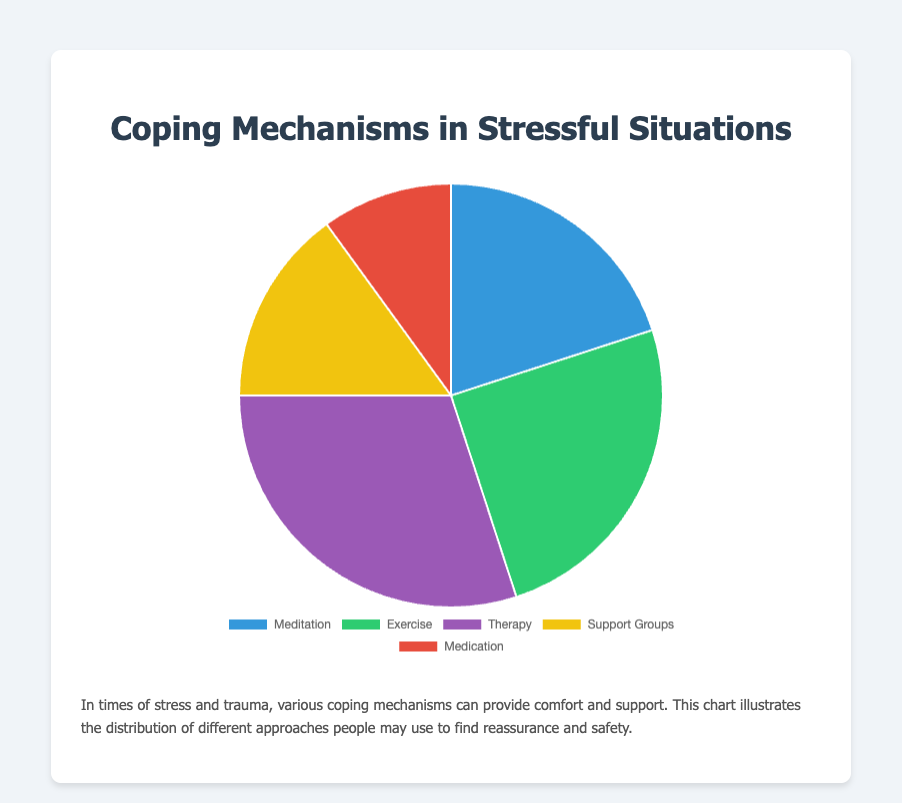What percentage of people use therapy as a coping mechanism? The figure shows that therapy accounts for 30% of the coping mechanisms used in stressful situations.
Answer: 30% Which coping mechanism is used more, exercise or meditation? By comparing the percentages, exercise is used by 25% of people, whereas meditation is used by 20%. Therefore, exercise is used more than meditation.
Answer: Exercise What is the total percentage of people who use either support groups or medication? According to the chart, support groups are used by 15% and medication by 10%. Summing these percentages: 15% + 10% = 25%.
Answer: 25% Which coping mechanism has the highest percentage? Based on the chart, therapy has the highest percentage at 30%.
Answer: Therapy What is the difference in usage percentage between the most and least used coping mechanisms? The most used coping mechanism is therapy at 30%, and the least used is medication at 10%. The difference is 30% - 10% = 20%.
Answer: 20% Which coping mechanism is represented by the blue color in the chart? The pie chart's blue segment represents meditation.
Answer: Meditation How much more popular is exercise compared to support groups? Exercise is used by 25% of people, while support groups are used by 15%. The difference is 25% - 15% = 10%.
Answer: 10% What percentage of people use non-physical coping mechanisms (therapy, support groups, medication)? Summing the percentages of therapy (30%), support groups (15%), and medication (10%): 30% + 15% + 10% = 55%.
Answer: 55% How many more people use therapy (30%) compared to those who use exercise (25%) and meditation (20%) combined? To find the combined percentage of exercise and meditation: 25% + 20% = 45%. Then, therapy (30%) is compared to this combination: 45% - 30% = 15%.
Answer: 15% Which coping mechanisms together make up exactly half of the reported usage? To find the combination that makes up 50%, adding smaller chunks is useful: Meditation (20%) + Support Groups (15%) + Medication (10%) = 45%, which is close but not exact. Exercise (25%) + Support Groups (15%) + Medication (10%) = 50%. These three mechanisms sum up to exactly 50%.
Answer: Exercise, Support Groups, and Medication 